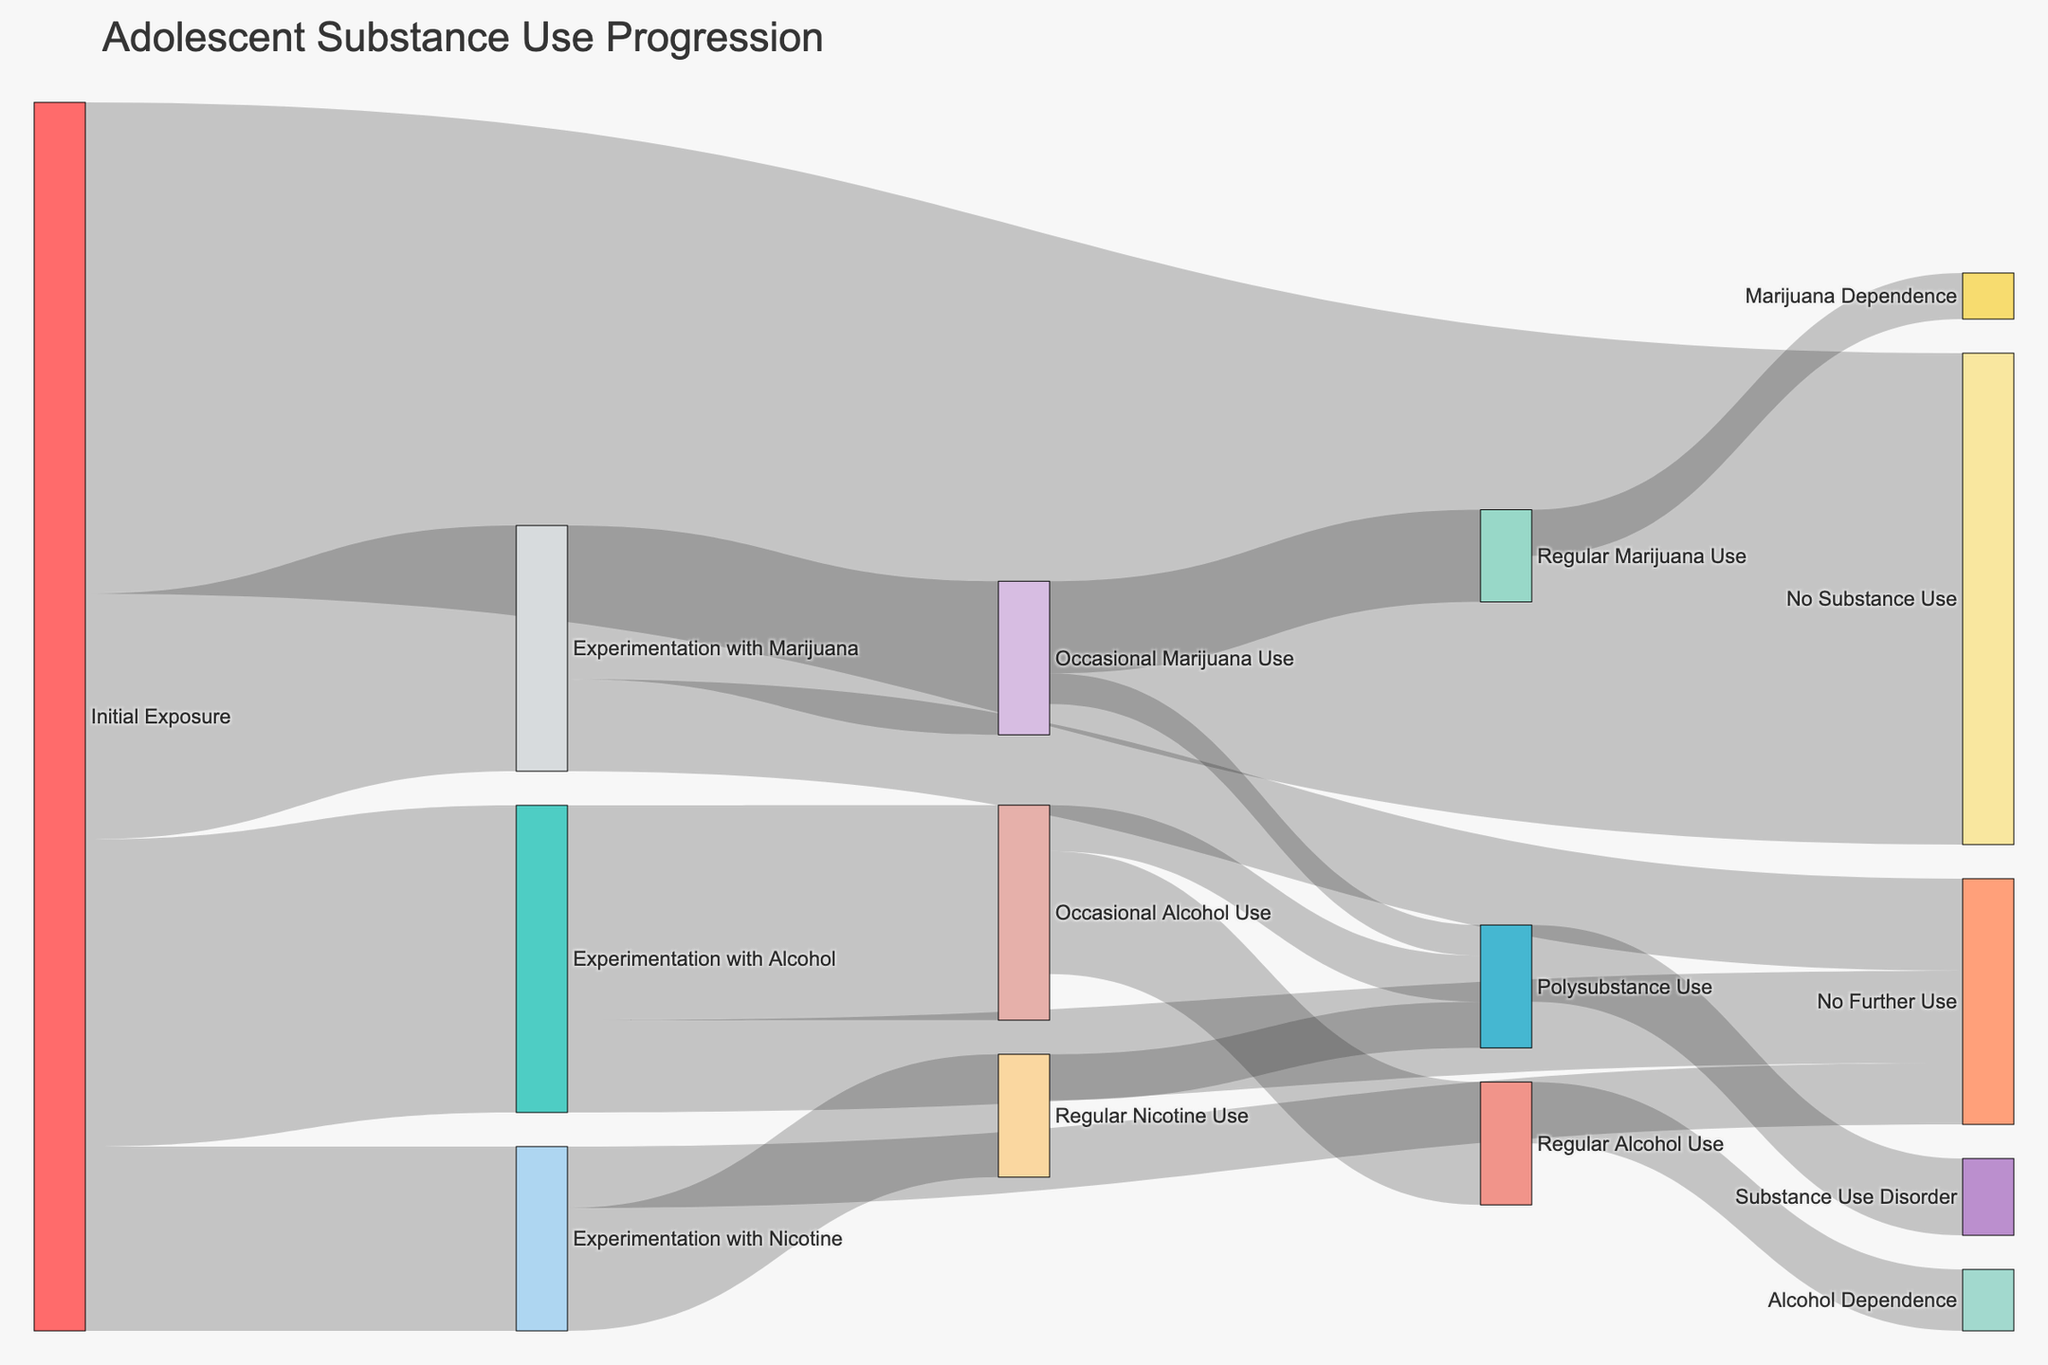What is the title of the diagram? The title of the diagram is usually located at the top of the figure. In this case, it reads "Adolescent Substance Use Progression" which provides context about the subject of the visualization.
Answer: Adolescent Substance Use Progression How many different stages are there from "Initial Exposure" to "No Substance Use"? To find the number of stages, count the connections from "Initial Exposure" leading directly to "No Substance Use." In this data, there is one direct connection labeled "No Substance Use."
Answer: 1 What is the total number of adolescents represented in the diagram? The value of each flow signifies the number of adolescents in each stage. Summing the values from the "Initial Exposure" stage gives us 1000 + 800 + 600 + 1600. Therefore, the total number is 4000.
Answer: 4000 How many adolescents progressed from "Experimentation with Alcohol" to "Regular Alcohol Use"? The diagram links "Experimentation with Alcohol" to "Occasional Alcohol Use," and then links "Occasional Alcohol Use" to "Regular Alcohol Use." Look at these connections: 700 from 'Experimentation with Alcohol' to 'Occasional Alcohol Use' and 400 from 'Occasional Alcohol Use' to 'Regular Alcohol Use.' Therefore, 400 adolescents progressed through these stages.
Answer: 400 Compare the number of adolescents that moved to "Regular Nicotine Use" with those who remained in "No Further Use" after experimenting with nicotine. Look at the flows branching from "Experimentation with Nicotine." The link to "Regular Nicotine Use" shows a value of 400, and the link to "No Further Use" shows a value of 200. Comparing these two values indicates more adolescents moved to 'Regular Nicotine Use.'
Answer: Regular Nicotine Use (400) is greater than No Further Use (200) How many adolescents develop into "Substance Use Disorder" from "Polysubstance Use"? The diagram has a direct link from "Polysubstance Use" to "Substance Use Disorder" which carries a value. This linkage shows the transition of 250 adolescents.
Answer: 250 Out of those who first experimented with marijuana, what fraction no longer used any substances afterward? The data shows that after "Experimentation with Marijuana," 300 adolescents used "No Further Use." Since initially 800 engaged in "Experimentation with Marijuana," the fraction is 300/800. Simplifying this, the fraction is 3/8.
Answer: 3/8 Calculate the total number of adolescents who exhibited "Regular Use" across all substances. To find the total, sum the values entering stages of "Regular Alcohol Use," "Regular Marijuana Use," and "Regular Nicotine Use." The values are 400, 300, and 400 respectively. So, the total number of adolescents exhibiting regular use is 400 + 300 + 400 = 1100.
Answer: 1100 Which stage has the highest number of adolescents remaining in "No Further Use"? Evaluating flows where "No Further Use" is a target, examine branches from "Experimentation with Alcohol," "Experimentation with Marijuana," and "Experimentation with Nicotine." The highest single value is from "Experimentation with Alcohol" to "No Further Use," which is 300.
Answer: Experimentation with Alcohol to No Further Use (300) What percentage of adolescents who occasionally used marijuana progressed to polysubstance use? From "Occasional Marijuana Use," 100 adolescents move to "Polysubstance Use." Initially, 500 engaged in "Occasional Marijuana Use." To determine the percentage, calculate (100/500) * 100%. This results in 20%.
Answer: 20% 